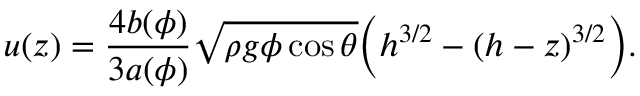<formula> <loc_0><loc_0><loc_500><loc_500>u ( z ) = \frac { 4 b ( \phi ) } { 3 a ( \phi ) } \sqrt { \rho g \phi \cos \theta } \left ( h ^ { 3 / 2 } - ( h - z ) ^ { 3 / 2 } \right ) .</formula> 